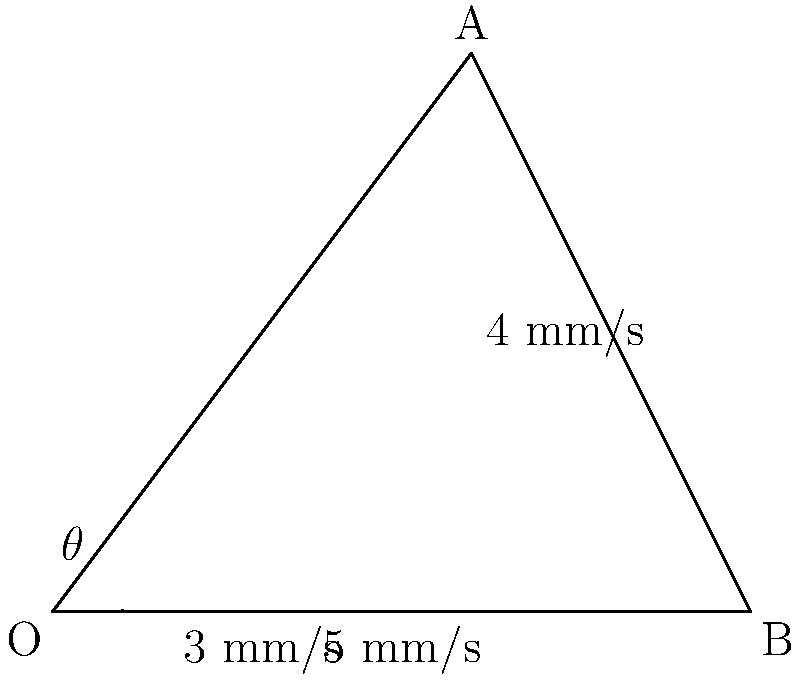A vibration sensor on a rotating bearing detects movement in two perpendicular directions. The horizontal component is measured as 3 mm/s, and the vertical component is 4 mm/s. What is the magnitude of the total vibration vector, and what angle does it make with the horizontal axis? To solve this problem, we'll use vector analysis:

1. Identify the components:
   - Horizontal component: $x = 3$ mm/s
   - Vertical component: $y = 4$ mm/s

2. Calculate the magnitude of the total vibration vector:
   Using the Pythagorean theorem:
   $$|v| = \sqrt{x^2 + y^2} = \sqrt{3^2 + 4^2} = \sqrt{9 + 16} = \sqrt{25} = 5$$ mm/s

3. Calculate the angle with the horizontal axis:
   Using the arctangent function:
   $$\theta = \tan^{-1}\left(\frac{y}{x}\right) = \tan^{-1}\left(\frac{4}{3}\right) \approx 53.13°$$

Therefore, the magnitude of the total vibration vector is 5 mm/s, and it makes an angle of approximately 53.13° with the horizontal axis.
Answer: 5 mm/s, 53.13° 